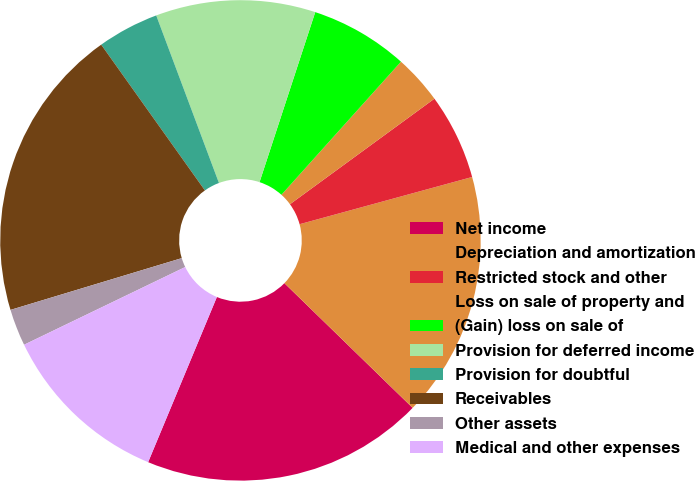Convert chart to OTSL. <chart><loc_0><loc_0><loc_500><loc_500><pie_chart><fcel>Net income<fcel>Depreciation and amortization<fcel>Restricted stock and other<fcel>Loss on sale of property and<fcel>(Gain) loss on sale of<fcel>Provision for deferred income<fcel>Provision for doubtful<fcel>Receivables<fcel>Other assets<fcel>Medical and other expenses<nl><fcel>19.0%<fcel>16.53%<fcel>5.79%<fcel>3.31%<fcel>6.61%<fcel>10.74%<fcel>4.14%<fcel>19.83%<fcel>2.48%<fcel>11.57%<nl></chart> 